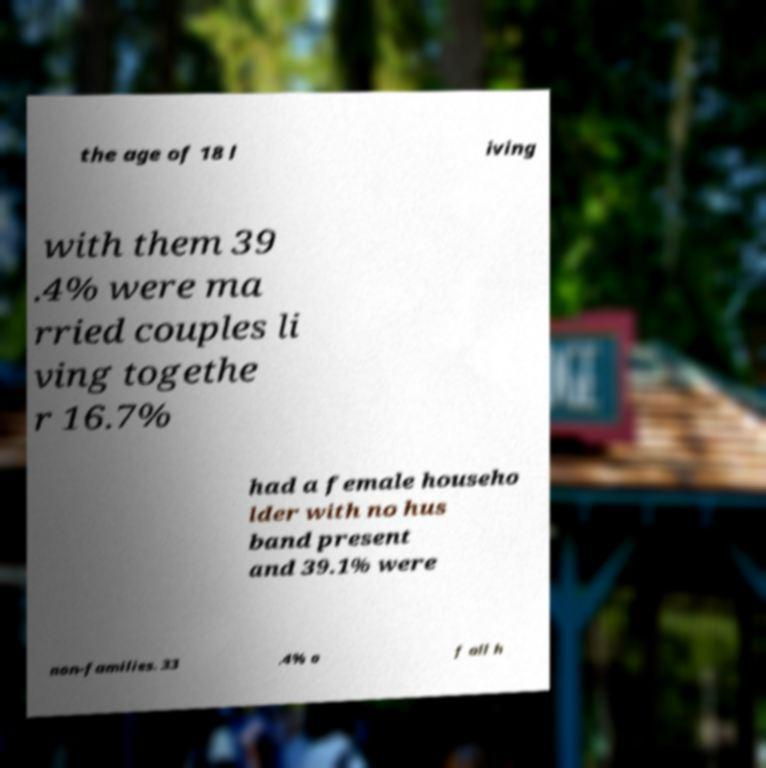Please read and relay the text visible in this image. What does it say? the age of 18 l iving with them 39 .4% were ma rried couples li ving togethe r 16.7% had a female househo lder with no hus band present and 39.1% were non-families. 33 .4% o f all h 